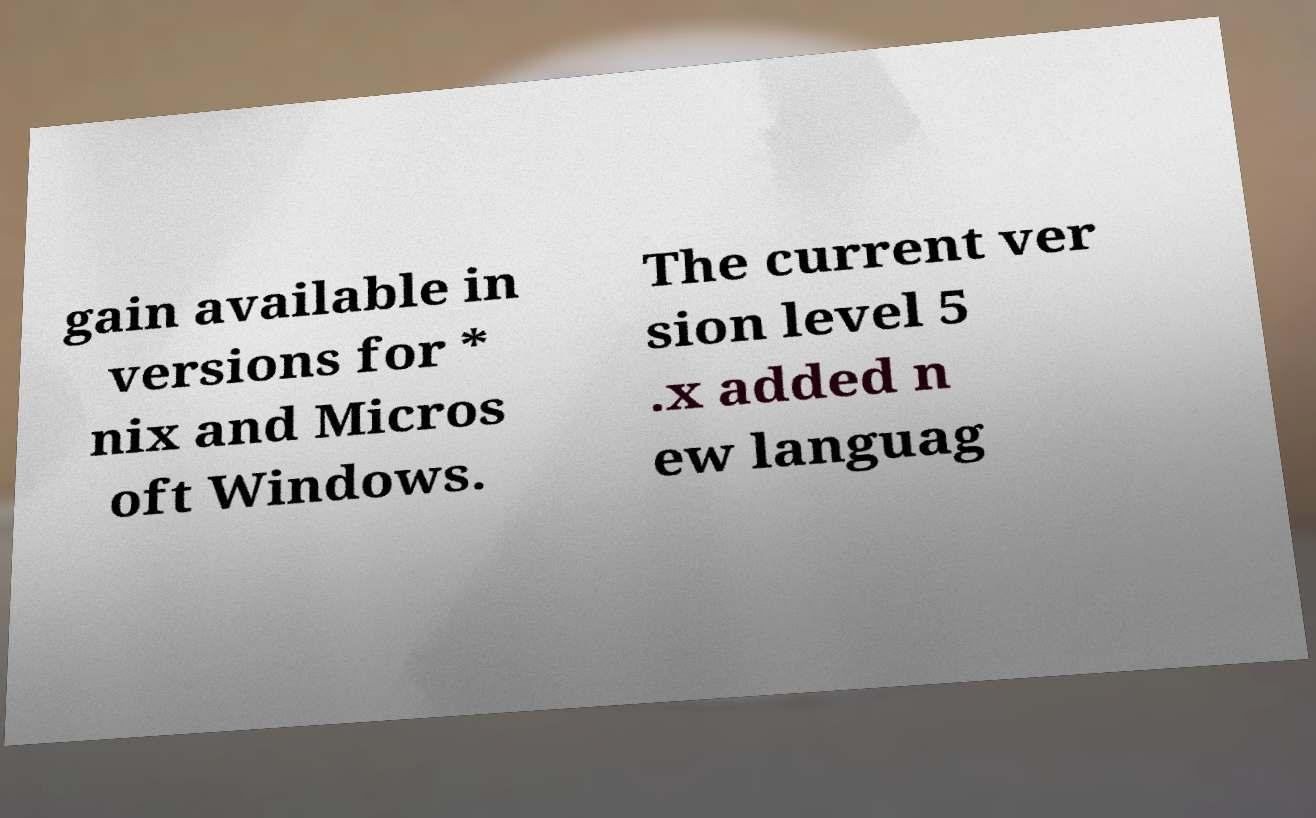For documentation purposes, I need the text within this image transcribed. Could you provide that? gain available in versions for * nix and Micros oft Windows. The current ver sion level 5 .x added n ew languag 